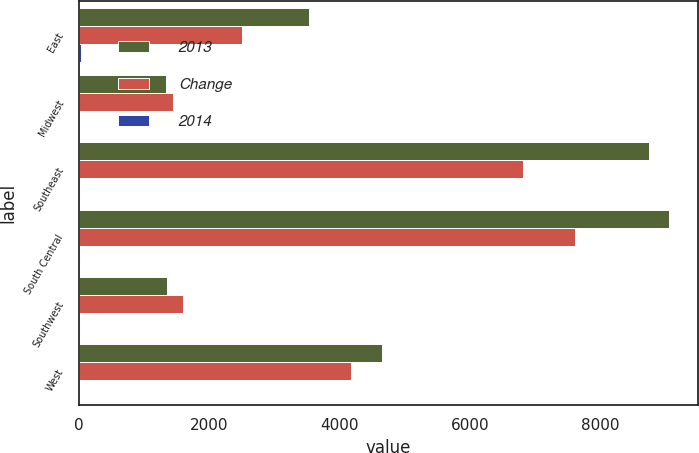<chart> <loc_0><loc_0><loc_500><loc_500><stacked_bar_chart><ecel><fcel>East<fcel>Midwest<fcel>Southeast<fcel>South Central<fcel>Southwest<fcel>West<nl><fcel>2013<fcel>3537<fcel>1342<fcel>8743<fcel>9046<fcel>1348<fcel>4654<nl><fcel>Change<fcel>2505<fcel>1449<fcel>6807<fcel>7609<fcel>1605<fcel>4180<nl><fcel>2014<fcel>41<fcel>7<fcel>28<fcel>19<fcel>16<fcel>11<nl></chart> 